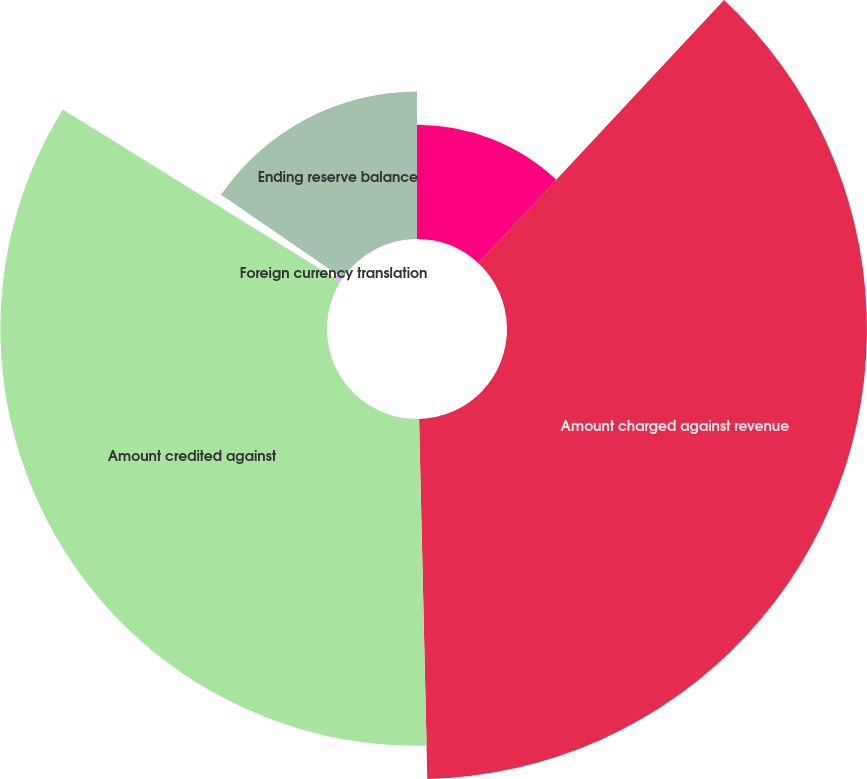<chart> <loc_0><loc_0><loc_500><loc_500><pie_chart><fcel>Beginning reserve balance<fcel>Amount charged against revenue<fcel>Amount credited against<fcel>Foreign currency translation<fcel>Ending reserve balance<nl><fcel>11.95%<fcel>37.68%<fcel>34.19%<fcel>0.73%<fcel>15.44%<nl></chart> 